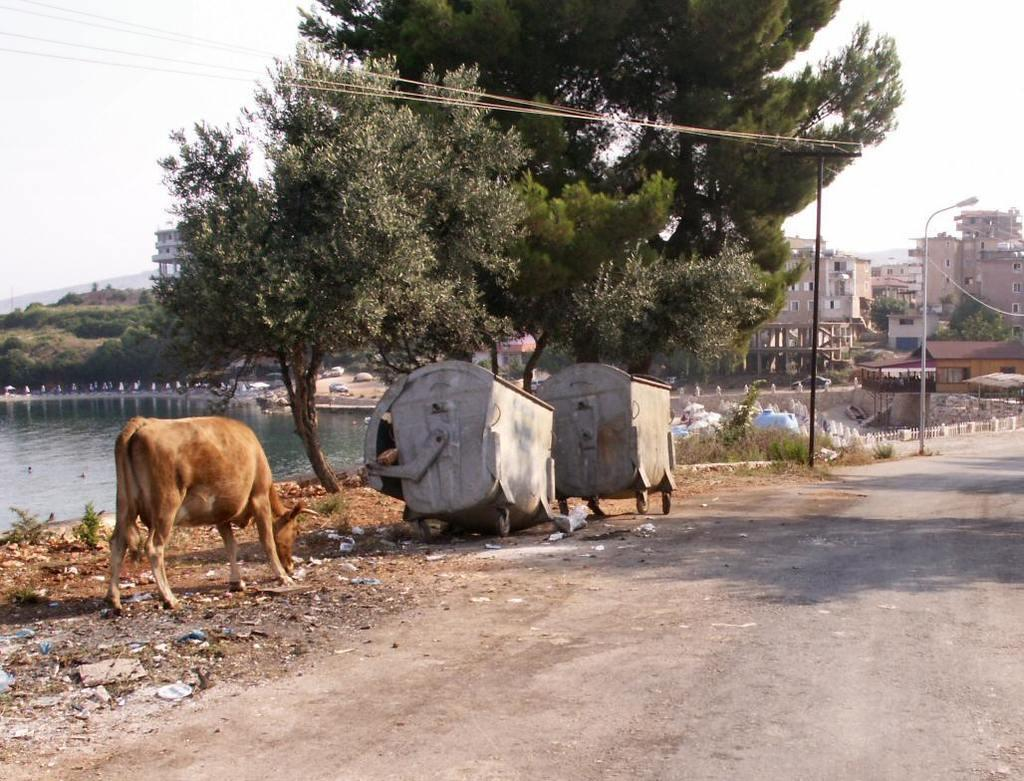What is the main feature of the image? There is a road in the image. What objects are located beside the road? There are dustbins beside the road. What type of animal can be seen in the image? There is a cow in the image. What natural elements are present in the image? There are trees and a pond in the image. What structures can be seen in the background of the image? There are poles and houses in the background of the image. What type of cup is being used to catch the cow's attention in the image? There is no cup present in the image, and the cow's attention is not being directed by any object. 